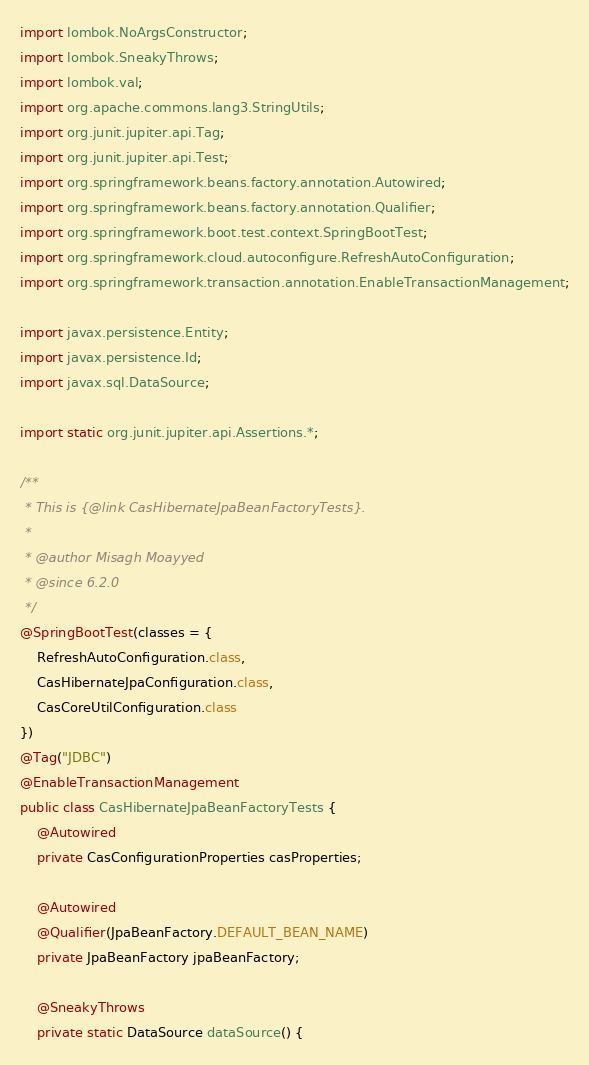Convert code to text. <code><loc_0><loc_0><loc_500><loc_500><_Java_>import lombok.NoArgsConstructor;
import lombok.SneakyThrows;
import lombok.val;
import org.apache.commons.lang3.StringUtils;
import org.junit.jupiter.api.Tag;
import org.junit.jupiter.api.Test;
import org.springframework.beans.factory.annotation.Autowired;
import org.springframework.beans.factory.annotation.Qualifier;
import org.springframework.boot.test.context.SpringBootTest;
import org.springframework.cloud.autoconfigure.RefreshAutoConfiguration;
import org.springframework.transaction.annotation.EnableTransactionManagement;

import javax.persistence.Entity;
import javax.persistence.Id;
import javax.sql.DataSource;

import static org.junit.jupiter.api.Assertions.*;

/**
 * This is {@link CasHibernateJpaBeanFactoryTests}.
 *
 * @author Misagh Moayyed
 * @since 6.2.0
 */
@SpringBootTest(classes = {
    RefreshAutoConfiguration.class,
    CasHibernateJpaConfiguration.class,
    CasCoreUtilConfiguration.class
})
@Tag("JDBC")
@EnableTransactionManagement
public class CasHibernateJpaBeanFactoryTests {
    @Autowired
    private CasConfigurationProperties casProperties;

    @Autowired
    @Qualifier(JpaBeanFactory.DEFAULT_BEAN_NAME)
    private JpaBeanFactory jpaBeanFactory;

    @SneakyThrows
    private static DataSource dataSource() {</code> 